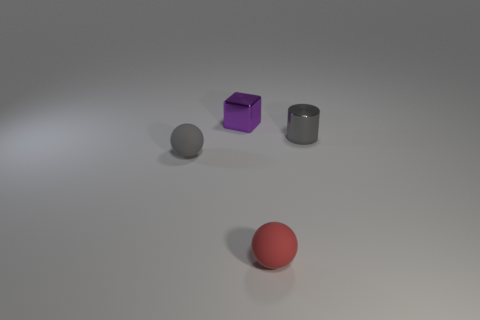Add 4 small gray cylinders. How many objects exist? 8 Subtract all red balls. How many balls are left? 1 Subtract all cylinders. How many objects are left? 3 Subtract 0 gray cubes. How many objects are left? 4 Subtract all green cylinders. Subtract all brown blocks. How many cylinders are left? 1 Subtract all gray blocks. How many green spheres are left? 0 Subtract all purple cubes. Subtract all red rubber objects. How many objects are left? 2 Add 4 rubber spheres. How many rubber spheres are left? 6 Add 1 big blue metal blocks. How many big blue metal blocks exist? 1 